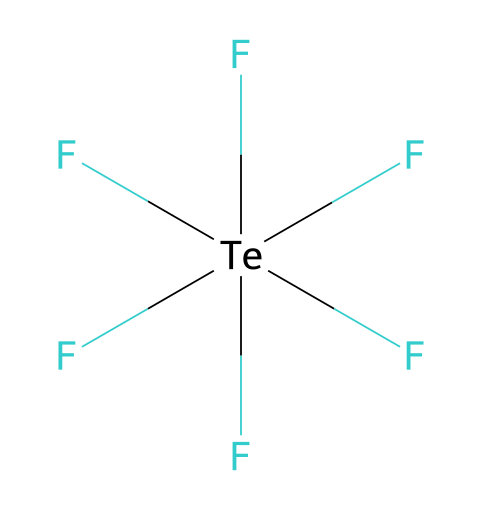What is the name of this compound? The SMILES representation indicates a tellurium atom surrounded by six fluorine atoms. The IUPAC name of this compound is derived from the element tellurium combined with the prefix for six (hexa) and the suffix for fluoride, resulting in "tellurium hexafluoride."
Answer: tellurium hexafluoride How many fluorine atoms are present in the structure? By observing the SMILES representation, there are five fluorine atoms indicated, as each `F` represents a fluorine atom directly bonded to the tellurium atom.
Answer: five Is tellurium hexafluoride a hypervalent compound? The presence of six fluorine atoms bonded to one tellurium atom allows for more than eight electrons surrounding the tellurium nucleus, fulfilling the criteria for hypervalency.
Answer: yes How many total atoms are in the compound? The structure consists of one tellurium atom and six fluorine atoms. Adding these gives a total count of seven atoms.
Answer: seven What type of bonds does tellurium hexafluoride contain? The chemical structure has single bonds between the tellurium atom and each of the fluorine atoms, as indicated by the SMILES representation with parentheses showing bonds.
Answer: single bonds What property allows tellurium hexafluoride to be used in solar panel manufacturing processes? Tellurium hexafluoride is highly reactive, which allows it to participate in chemical reactions during the deposition processes used to produce photovoltaic cells for solar panels, enhancing their efficiency.
Answer: reactivity 